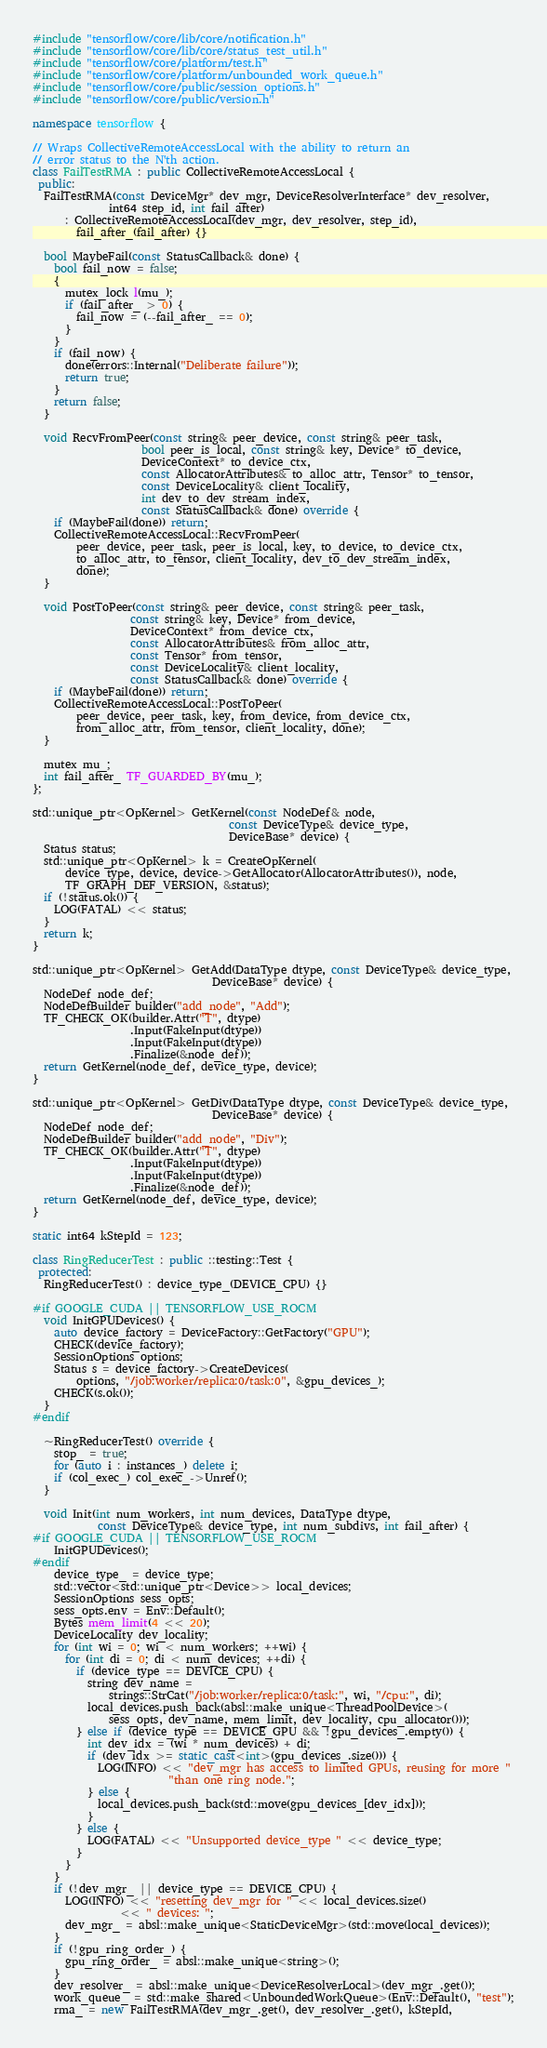<code> <loc_0><loc_0><loc_500><loc_500><_C++_>#include "tensorflow/core/lib/core/notification.h"
#include "tensorflow/core/lib/core/status_test_util.h"
#include "tensorflow/core/platform/test.h"
#include "tensorflow/core/platform/unbounded_work_queue.h"
#include "tensorflow/core/public/session_options.h"
#include "tensorflow/core/public/version.h"

namespace tensorflow {

// Wraps CollectiveRemoteAccessLocal with the ability to return an
// error status to the N'th action.
class FailTestRMA : public CollectiveRemoteAccessLocal {
 public:
  FailTestRMA(const DeviceMgr* dev_mgr, DeviceResolverInterface* dev_resolver,
              int64 step_id, int fail_after)
      : CollectiveRemoteAccessLocal(dev_mgr, dev_resolver, step_id),
        fail_after_(fail_after) {}

  bool MaybeFail(const StatusCallback& done) {
    bool fail_now = false;
    {
      mutex_lock l(mu_);
      if (fail_after_ > 0) {
        fail_now = (--fail_after_ == 0);
      }
    }
    if (fail_now) {
      done(errors::Internal("Deliberate failure"));
      return true;
    }
    return false;
  }

  void RecvFromPeer(const string& peer_device, const string& peer_task,
                    bool peer_is_local, const string& key, Device* to_device,
                    DeviceContext* to_device_ctx,
                    const AllocatorAttributes& to_alloc_attr, Tensor* to_tensor,
                    const DeviceLocality& client_locality,
                    int dev_to_dev_stream_index,
                    const StatusCallback& done) override {
    if (MaybeFail(done)) return;
    CollectiveRemoteAccessLocal::RecvFromPeer(
        peer_device, peer_task, peer_is_local, key, to_device, to_device_ctx,
        to_alloc_attr, to_tensor, client_locality, dev_to_dev_stream_index,
        done);
  }

  void PostToPeer(const string& peer_device, const string& peer_task,
                  const string& key, Device* from_device,
                  DeviceContext* from_device_ctx,
                  const AllocatorAttributes& from_alloc_attr,
                  const Tensor* from_tensor,
                  const DeviceLocality& client_locality,
                  const StatusCallback& done) override {
    if (MaybeFail(done)) return;
    CollectiveRemoteAccessLocal::PostToPeer(
        peer_device, peer_task, key, from_device, from_device_ctx,
        from_alloc_attr, from_tensor, client_locality, done);
  }

  mutex mu_;
  int fail_after_ TF_GUARDED_BY(mu_);
};

std::unique_ptr<OpKernel> GetKernel(const NodeDef& node,
                                    const DeviceType& device_type,
                                    DeviceBase* device) {
  Status status;
  std::unique_ptr<OpKernel> k = CreateOpKernel(
      device_type, device, device->GetAllocator(AllocatorAttributes()), node,
      TF_GRAPH_DEF_VERSION, &status);
  if (!status.ok()) {
    LOG(FATAL) << status;
  }
  return k;
}

std::unique_ptr<OpKernel> GetAdd(DataType dtype, const DeviceType& device_type,
                                 DeviceBase* device) {
  NodeDef node_def;
  NodeDefBuilder builder("add_node", "Add");
  TF_CHECK_OK(builder.Attr("T", dtype)
                  .Input(FakeInput(dtype))
                  .Input(FakeInput(dtype))
                  .Finalize(&node_def));
  return GetKernel(node_def, device_type, device);
}

std::unique_ptr<OpKernel> GetDiv(DataType dtype, const DeviceType& device_type,
                                 DeviceBase* device) {
  NodeDef node_def;
  NodeDefBuilder builder("add_node", "Div");
  TF_CHECK_OK(builder.Attr("T", dtype)
                  .Input(FakeInput(dtype))
                  .Input(FakeInput(dtype))
                  .Finalize(&node_def));
  return GetKernel(node_def, device_type, device);
}

static int64 kStepId = 123;

class RingReducerTest : public ::testing::Test {
 protected:
  RingReducerTest() : device_type_(DEVICE_CPU) {}

#if GOOGLE_CUDA || TENSORFLOW_USE_ROCM
  void InitGPUDevices() {
    auto device_factory = DeviceFactory::GetFactory("GPU");
    CHECK(device_factory);
    SessionOptions options;
    Status s = device_factory->CreateDevices(
        options, "/job:worker/replica:0/task:0", &gpu_devices_);
    CHECK(s.ok());
  }
#endif

  ~RingReducerTest() override {
    stop_ = true;
    for (auto i : instances_) delete i;
    if (col_exec_) col_exec_->Unref();
  }

  void Init(int num_workers, int num_devices, DataType dtype,
            const DeviceType& device_type, int num_subdivs, int fail_after) {
#if GOOGLE_CUDA || TENSORFLOW_USE_ROCM
    InitGPUDevices();
#endif
    device_type_ = device_type;
    std::vector<std::unique_ptr<Device>> local_devices;
    SessionOptions sess_opts;
    sess_opts.env = Env::Default();
    Bytes mem_limit(4 << 20);
    DeviceLocality dev_locality;
    for (int wi = 0; wi < num_workers; ++wi) {
      for (int di = 0; di < num_devices; ++di) {
        if (device_type == DEVICE_CPU) {
          string dev_name =
              strings::StrCat("/job:worker/replica:0/task:", wi, "/cpu:", di);
          local_devices.push_back(absl::make_unique<ThreadPoolDevice>(
              sess_opts, dev_name, mem_limit, dev_locality, cpu_allocator()));
        } else if (device_type == DEVICE_GPU && !gpu_devices_.empty()) {
          int dev_idx = (wi * num_devices) + di;
          if (dev_idx >= static_cast<int>(gpu_devices_.size())) {
            LOG(INFO) << "dev_mgr has access to limited GPUs, reusing for more "
                         "than one ring node.";
          } else {
            local_devices.push_back(std::move(gpu_devices_[dev_idx]));
          }
        } else {
          LOG(FATAL) << "Unsupported device_type " << device_type;
        }
      }
    }
    if (!dev_mgr_ || device_type == DEVICE_CPU) {
      LOG(INFO) << "resetting dev_mgr for " << local_devices.size()
                << " devices: ";
      dev_mgr_ = absl::make_unique<StaticDeviceMgr>(std::move(local_devices));
    }
    if (!gpu_ring_order_) {
      gpu_ring_order_ = absl::make_unique<string>();
    }
    dev_resolver_ = absl::make_unique<DeviceResolverLocal>(dev_mgr_.get());
    work_queue_ = std::make_shared<UnboundedWorkQueue>(Env::Default(), "test");
    rma_ = new FailTestRMA(dev_mgr_.get(), dev_resolver_.get(), kStepId,</code> 